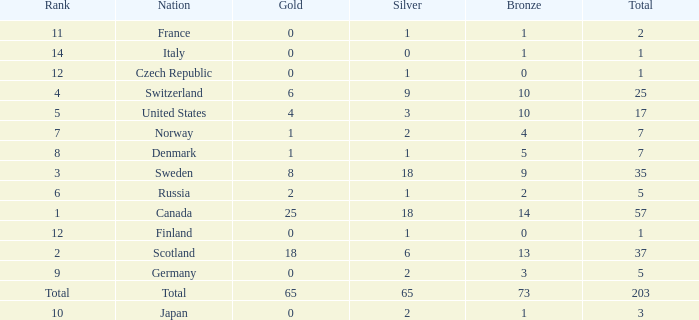What is the number of bronze medals when the total is greater than 1, more than 2 silver medals are won, and the rank is 2? 13.0. 